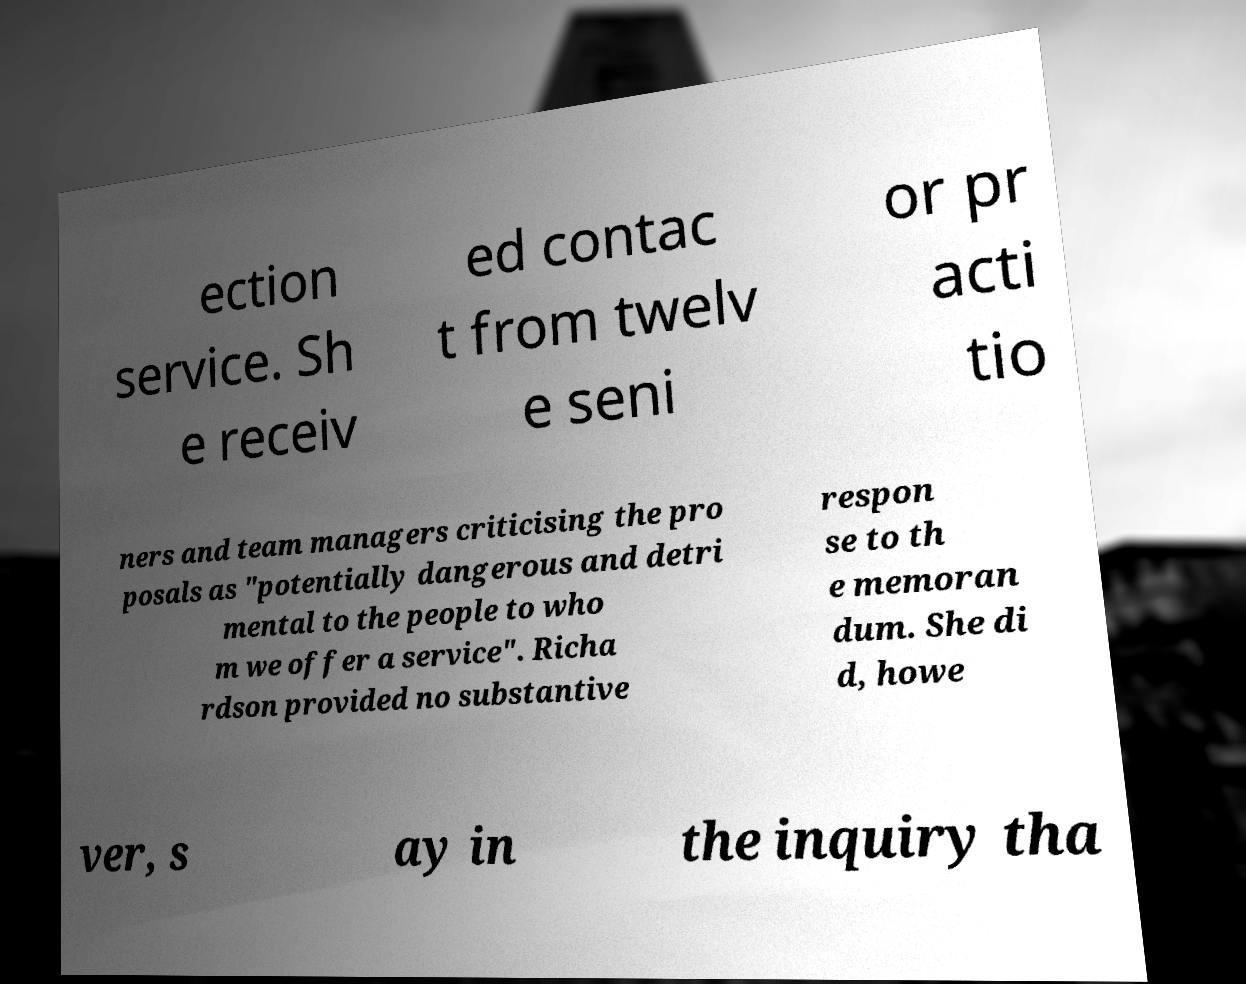Can you accurately transcribe the text from the provided image for me? ection service. Sh e receiv ed contac t from twelv e seni or pr acti tio ners and team managers criticising the pro posals as "potentially dangerous and detri mental to the people to who m we offer a service". Richa rdson provided no substantive respon se to th e memoran dum. She di d, howe ver, s ay in the inquiry tha 